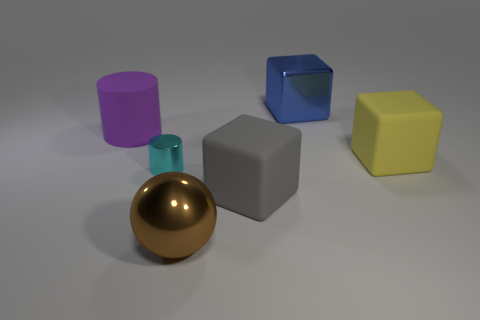What is the size of the cube behind the matte cube that is behind the matte thing that is in front of the yellow cube? The cube behind the matte cube, which is located in front of the yellow cube, appears to be of a medium size compared to the other objects in the scene. 